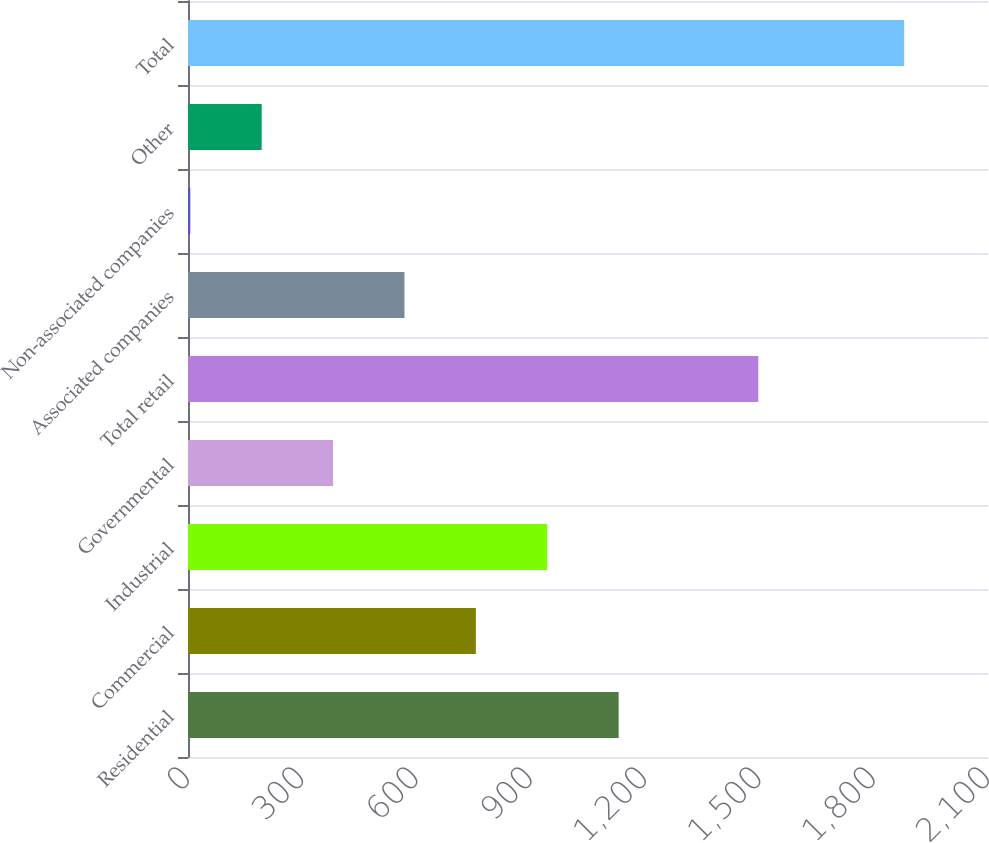Convert chart. <chart><loc_0><loc_0><loc_500><loc_500><bar_chart><fcel>Residential<fcel>Commercial<fcel>Industrial<fcel>Governmental<fcel>Total retail<fcel>Associated companies<fcel>Non-associated companies<fcel>Other<fcel>Total<nl><fcel>1130.4<fcel>755.6<fcel>943<fcel>380.8<fcel>1497<fcel>568.2<fcel>6<fcel>193.4<fcel>1880<nl></chart> 